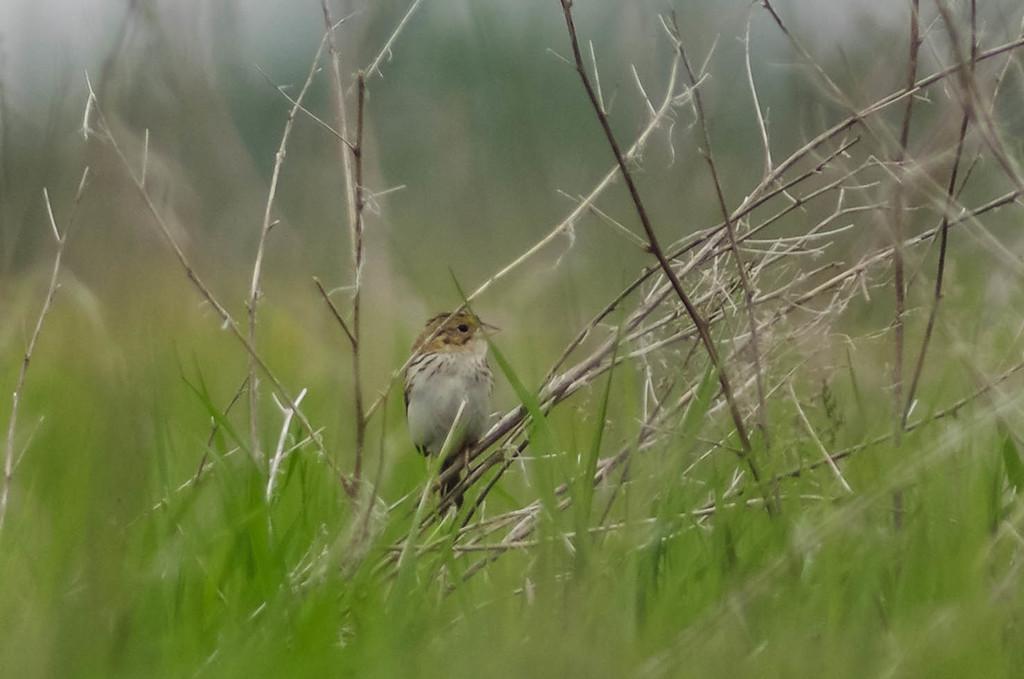How would you summarize this image in a sentence or two? In this picture i can see a bird is sitting on plant. I can also see grass. 